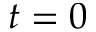<formula> <loc_0><loc_0><loc_500><loc_500>t = 0</formula> 